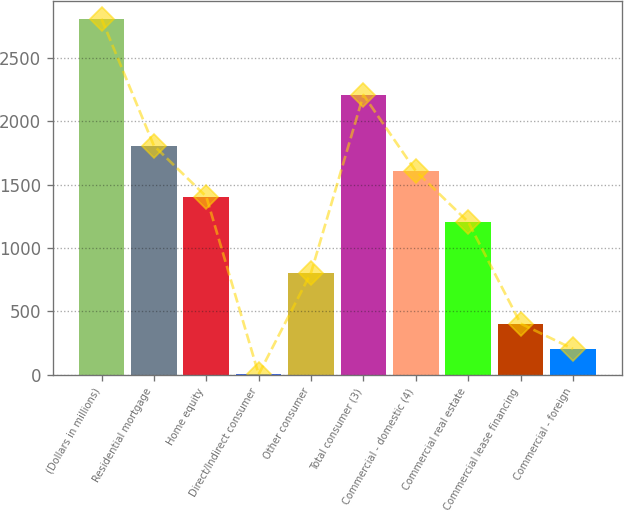<chart> <loc_0><loc_0><loc_500><loc_500><bar_chart><fcel>(Dollars in millions)<fcel>Residential mortgage<fcel>Home equity<fcel>Direct/Indirect consumer<fcel>Other consumer<fcel>Total consumer (3)<fcel>Commercial - domestic (4)<fcel>Commercial real estate<fcel>Commercial lease financing<fcel>Commercial - foreign<nl><fcel>2806.8<fcel>1805.8<fcel>1405.4<fcel>4<fcel>804.8<fcel>2206.2<fcel>1605.6<fcel>1205.2<fcel>404.4<fcel>204.2<nl></chart> 